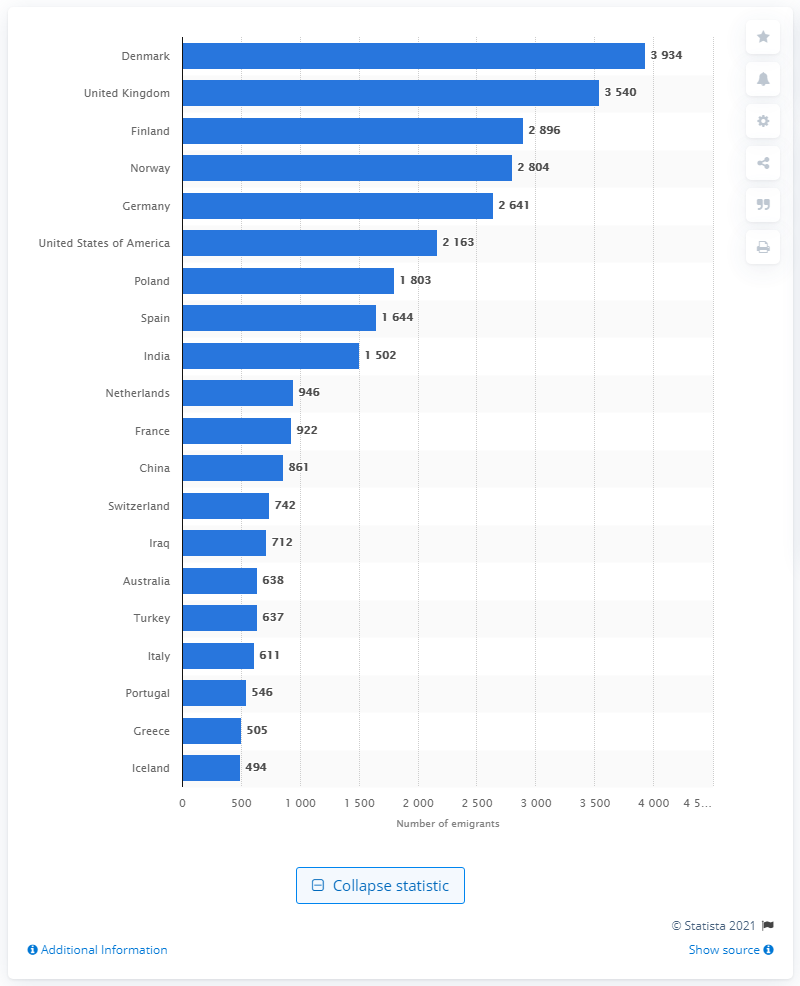Give some essential details in this illustration. In 2020, the highest number of Swedish emigrants moved to Denmark. Norway came in third for emigration. The second most common country for emigration was the United Kingdom. 